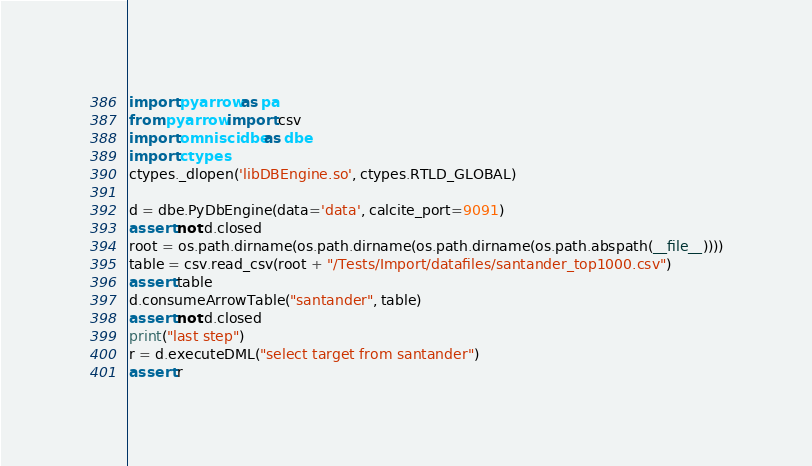<code> <loc_0><loc_0><loc_500><loc_500><_Python_>import pyarrow as pa
from pyarrow import csv
import omniscidbe as dbe
import ctypes
ctypes._dlopen('libDBEngine.so', ctypes.RTLD_GLOBAL)

d = dbe.PyDbEngine(data='data', calcite_port=9091)
assert not d.closed
root = os.path.dirname(os.path.dirname(os.path.dirname(os.path.abspath(__file__))))
table = csv.read_csv(root + "/Tests/Import/datafiles/santander_top1000.csv")
assert table
d.consumeArrowTable("santander", table)
assert not d.closed
print("last step")
r = d.executeDML("select target from santander")
assert r
</code> 